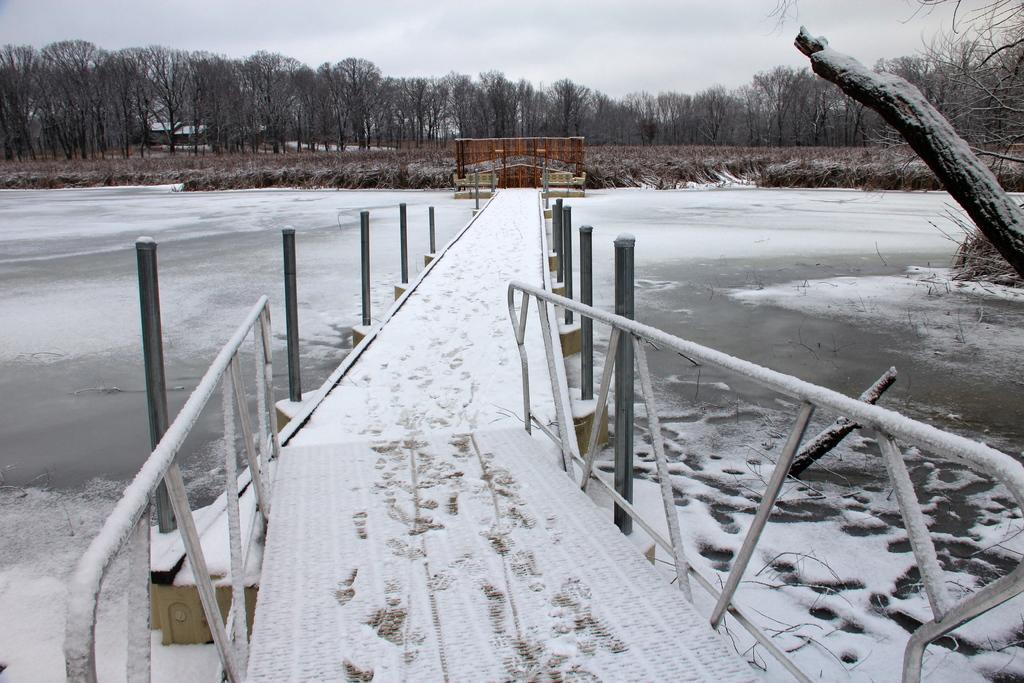Describe this image in one or two sentences. In this image there is a bridge on a lake, the lake is covered with snow, in the background there is are trees and a sky. 